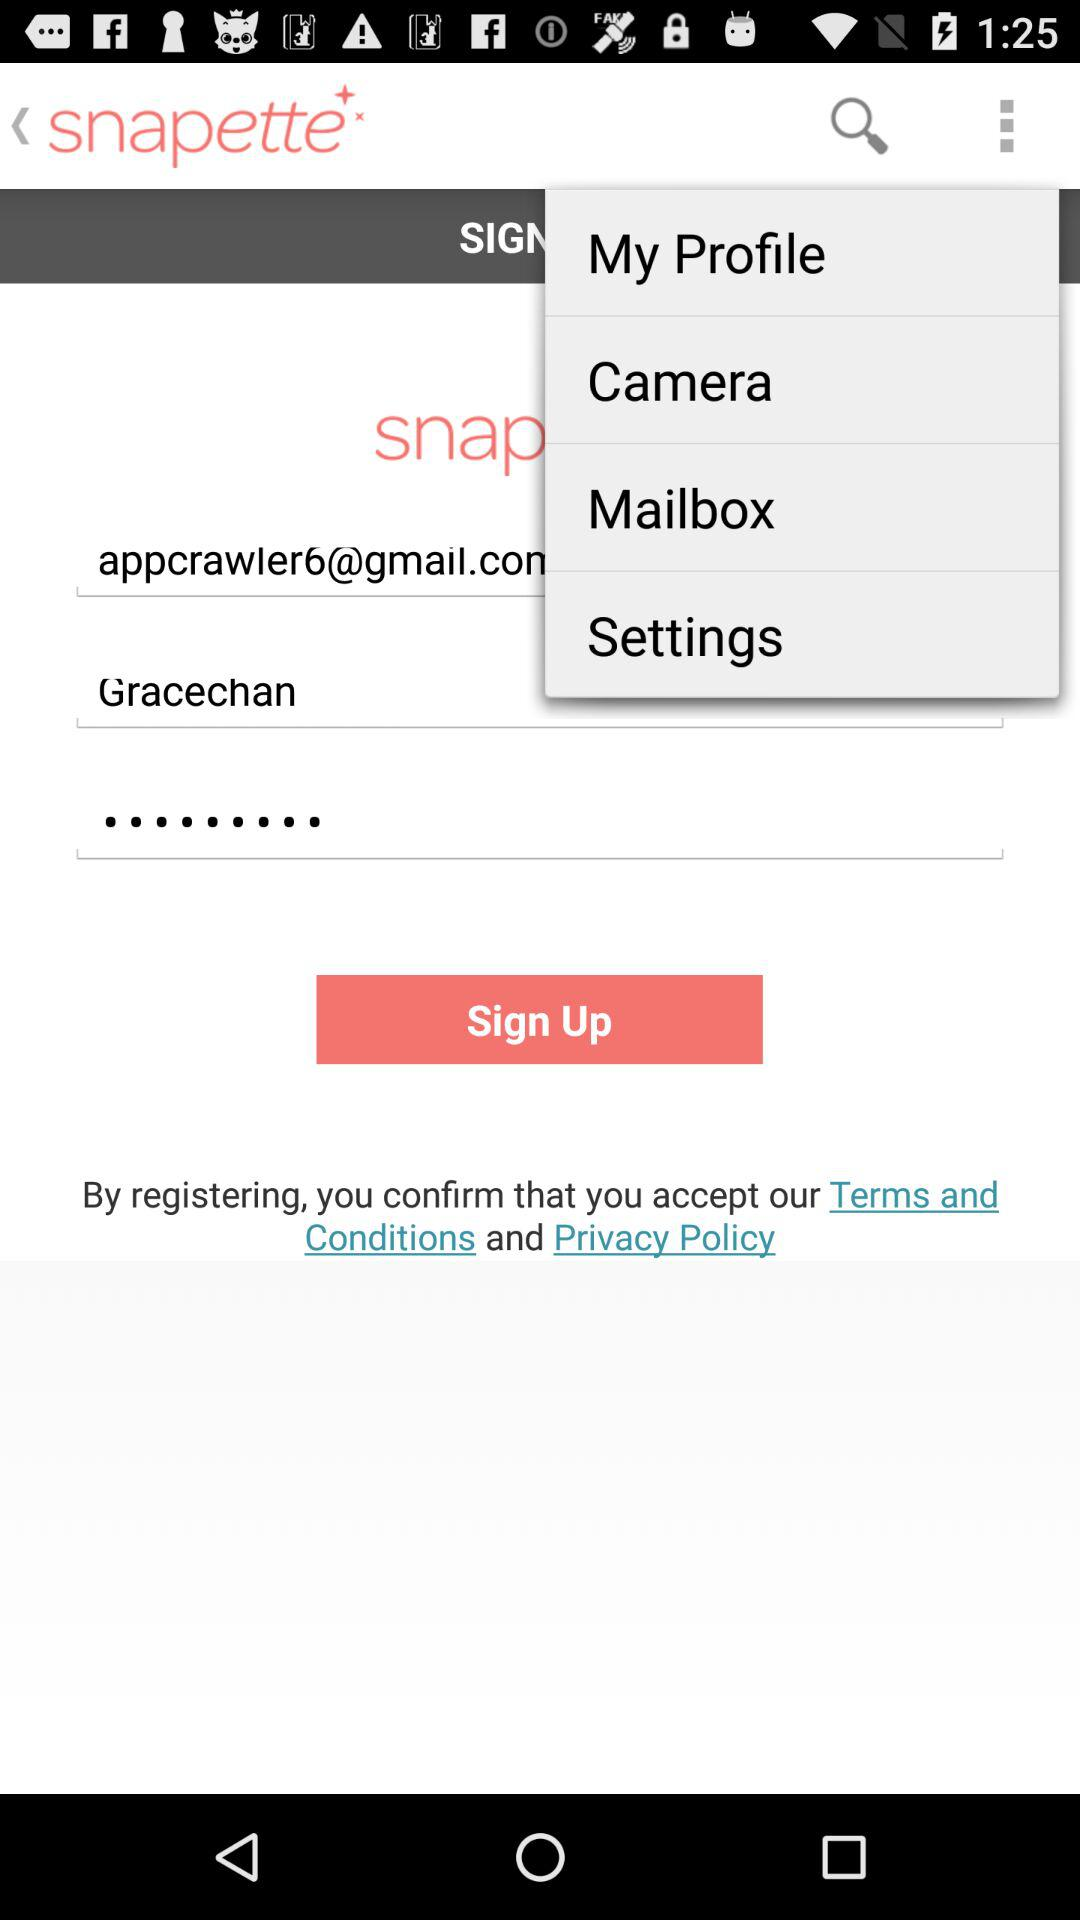How to pronounce his name?
When the provided information is insufficient, respond with <no answer>. <no answer> 